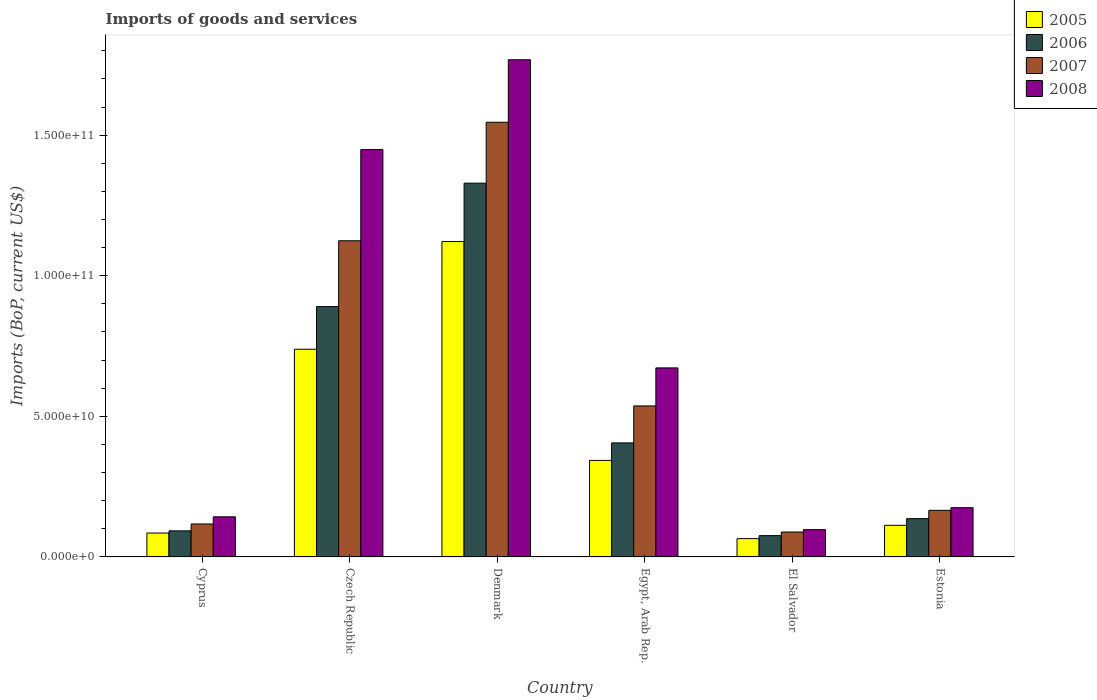How many different coloured bars are there?
Provide a succinct answer. 4. How many groups of bars are there?
Give a very brief answer. 6. Are the number of bars per tick equal to the number of legend labels?
Provide a short and direct response. Yes. Are the number of bars on each tick of the X-axis equal?
Your answer should be very brief. Yes. How many bars are there on the 2nd tick from the right?
Your answer should be very brief. 4. What is the label of the 2nd group of bars from the left?
Keep it short and to the point. Czech Republic. What is the amount spent on imports in 2007 in El Salvador?
Your answer should be very brief. 8.86e+09. Across all countries, what is the maximum amount spent on imports in 2005?
Offer a very short reply. 1.12e+11. Across all countries, what is the minimum amount spent on imports in 2005?
Your answer should be compact. 6.51e+09. In which country was the amount spent on imports in 2005 minimum?
Provide a succinct answer. El Salvador. What is the total amount spent on imports in 2005 in the graph?
Make the answer very short. 2.47e+11. What is the difference between the amount spent on imports in 2006 in Czech Republic and that in Egypt, Arab Rep.?
Offer a very short reply. 4.85e+1. What is the difference between the amount spent on imports in 2005 in Estonia and the amount spent on imports in 2006 in Denmark?
Ensure brevity in your answer.  -1.22e+11. What is the average amount spent on imports in 2008 per country?
Make the answer very short. 7.17e+1. What is the difference between the amount spent on imports of/in 2007 and amount spent on imports of/in 2006 in Cyprus?
Your response must be concise. 2.45e+09. In how many countries, is the amount spent on imports in 2007 greater than 100000000000 US$?
Provide a short and direct response. 2. What is the ratio of the amount spent on imports in 2006 in Egypt, Arab Rep. to that in Estonia?
Make the answer very short. 2.98. Is the amount spent on imports in 2008 in Czech Republic less than that in Estonia?
Your response must be concise. No. What is the difference between the highest and the second highest amount spent on imports in 2006?
Offer a very short reply. 9.24e+1. What is the difference between the highest and the lowest amount spent on imports in 2006?
Make the answer very short. 1.25e+11. Is the sum of the amount spent on imports in 2007 in Denmark and Estonia greater than the maximum amount spent on imports in 2005 across all countries?
Make the answer very short. Yes. What does the 4th bar from the left in Egypt, Arab Rep. represents?
Your answer should be very brief. 2008. What does the 1st bar from the right in Denmark represents?
Provide a short and direct response. 2008. Is it the case that in every country, the sum of the amount spent on imports in 2005 and amount spent on imports in 2007 is greater than the amount spent on imports in 2008?
Your response must be concise. Yes. How many bars are there?
Your answer should be very brief. 24. How many countries are there in the graph?
Offer a terse response. 6. What is the difference between two consecutive major ticks on the Y-axis?
Your response must be concise. 5.00e+1. Are the values on the major ticks of Y-axis written in scientific E-notation?
Your response must be concise. Yes. Does the graph contain any zero values?
Your answer should be compact. No. Does the graph contain grids?
Your answer should be very brief. No. How many legend labels are there?
Your answer should be very brief. 4. What is the title of the graph?
Provide a short and direct response. Imports of goods and services. What is the label or title of the Y-axis?
Your answer should be compact. Imports (BoP, current US$). What is the Imports (BoP, current US$) in 2005 in Cyprus?
Provide a succinct answer. 8.50e+09. What is the Imports (BoP, current US$) in 2006 in Cyprus?
Provide a short and direct response. 9.27e+09. What is the Imports (BoP, current US$) in 2007 in Cyprus?
Provide a short and direct response. 1.17e+1. What is the Imports (BoP, current US$) of 2008 in Cyprus?
Your answer should be compact. 1.43e+1. What is the Imports (BoP, current US$) of 2005 in Czech Republic?
Keep it short and to the point. 7.39e+1. What is the Imports (BoP, current US$) in 2006 in Czech Republic?
Make the answer very short. 8.90e+1. What is the Imports (BoP, current US$) of 2007 in Czech Republic?
Your response must be concise. 1.12e+11. What is the Imports (BoP, current US$) of 2008 in Czech Republic?
Ensure brevity in your answer.  1.45e+11. What is the Imports (BoP, current US$) in 2005 in Denmark?
Your answer should be compact. 1.12e+11. What is the Imports (BoP, current US$) of 2006 in Denmark?
Offer a terse response. 1.33e+11. What is the Imports (BoP, current US$) of 2007 in Denmark?
Make the answer very short. 1.55e+11. What is the Imports (BoP, current US$) in 2008 in Denmark?
Your answer should be very brief. 1.77e+11. What is the Imports (BoP, current US$) of 2005 in Egypt, Arab Rep.?
Offer a terse response. 3.43e+1. What is the Imports (BoP, current US$) in 2006 in Egypt, Arab Rep.?
Provide a succinct answer. 4.06e+1. What is the Imports (BoP, current US$) of 2007 in Egypt, Arab Rep.?
Make the answer very short. 5.37e+1. What is the Imports (BoP, current US$) in 2008 in Egypt, Arab Rep.?
Ensure brevity in your answer.  6.72e+1. What is the Imports (BoP, current US$) in 2005 in El Salvador?
Your answer should be compact. 6.51e+09. What is the Imports (BoP, current US$) in 2006 in El Salvador?
Make the answer very short. 7.57e+09. What is the Imports (BoP, current US$) in 2007 in El Salvador?
Your answer should be compact. 8.86e+09. What is the Imports (BoP, current US$) in 2008 in El Salvador?
Provide a short and direct response. 9.70e+09. What is the Imports (BoP, current US$) of 2005 in Estonia?
Provide a short and direct response. 1.12e+1. What is the Imports (BoP, current US$) of 2006 in Estonia?
Give a very brief answer. 1.36e+1. What is the Imports (BoP, current US$) of 2007 in Estonia?
Your answer should be compact. 1.66e+1. What is the Imports (BoP, current US$) of 2008 in Estonia?
Give a very brief answer. 1.75e+1. Across all countries, what is the maximum Imports (BoP, current US$) of 2005?
Offer a terse response. 1.12e+11. Across all countries, what is the maximum Imports (BoP, current US$) in 2006?
Offer a very short reply. 1.33e+11. Across all countries, what is the maximum Imports (BoP, current US$) of 2007?
Ensure brevity in your answer.  1.55e+11. Across all countries, what is the maximum Imports (BoP, current US$) in 2008?
Ensure brevity in your answer.  1.77e+11. Across all countries, what is the minimum Imports (BoP, current US$) in 2005?
Your response must be concise. 6.51e+09. Across all countries, what is the minimum Imports (BoP, current US$) of 2006?
Ensure brevity in your answer.  7.57e+09. Across all countries, what is the minimum Imports (BoP, current US$) of 2007?
Your answer should be very brief. 8.86e+09. Across all countries, what is the minimum Imports (BoP, current US$) in 2008?
Your answer should be very brief. 9.70e+09. What is the total Imports (BoP, current US$) of 2005 in the graph?
Keep it short and to the point. 2.47e+11. What is the total Imports (BoP, current US$) in 2006 in the graph?
Offer a very short reply. 2.93e+11. What is the total Imports (BoP, current US$) of 2007 in the graph?
Make the answer very short. 3.58e+11. What is the total Imports (BoP, current US$) in 2008 in the graph?
Give a very brief answer. 4.30e+11. What is the difference between the Imports (BoP, current US$) of 2005 in Cyprus and that in Czech Republic?
Provide a short and direct response. -6.54e+1. What is the difference between the Imports (BoP, current US$) in 2006 in Cyprus and that in Czech Republic?
Your response must be concise. -7.97e+1. What is the difference between the Imports (BoP, current US$) of 2007 in Cyprus and that in Czech Republic?
Keep it short and to the point. -1.01e+11. What is the difference between the Imports (BoP, current US$) in 2008 in Cyprus and that in Czech Republic?
Make the answer very short. -1.31e+11. What is the difference between the Imports (BoP, current US$) in 2005 in Cyprus and that in Denmark?
Ensure brevity in your answer.  -1.04e+11. What is the difference between the Imports (BoP, current US$) in 2006 in Cyprus and that in Denmark?
Offer a very short reply. -1.24e+11. What is the difference between the Imports (BoP, current US$) in 2007 in Cyprus and that in Denmark?
Provide a short and direct response. -1.43e+11. What is the difference between the Imports (BoP, current US$) in 2008 in Cyprus and that in Denmark?
Make the answer very short. -1.63e+11. What is the difference between the Imports (BoP, current US$) of 2005 in Cyprus and that in Egypt, Arab Rep.?
Offer a terse response. -2.58e+1. What is the difference between the Imports (BoP, current US$) of 2006 in Cyprus and that in Egypt, Arab Rep.?
Offer a very short reply. -3.13e+1. What is the difference between the Imports (BoP, current US$) of 2007 in Cyprus and that in Egypt, Arab Rep.?
Provide a short and direct response. -4.20e+1. What is the difference between the Imports (BoP, current US$) of 2008 in Cyprus and that in Egypt, Arab Rep.?
Your response must be concise. -5.30e+1. What is the difference between the Imports (BoP, current US$) in 2005 in Cyprus and that in El Salvador?
Keep it short and to the point. 1.99e+09. What is the difference between the Imports (BoP, current US$) of 2006 in Cyprus and that in El Salvador?
Offer a very short reply. 1.70e+09. What is the difference between the Imports (BoP, current US$) in 2007 in Cyprus and that in El Salvador?
Keep it short and to the point. 2.87e+09. What is the difference between the Imports (BoP, current US$) of 2008 in Cyprus and that in El Salvador?
Offer a terse response. 4.56e+09. What is the difference between the Imports (BoP, current US$) in 2005 in Cyprus and that in Estonia?
Your answer should be compact. -2.75e+09. What is the difference between the Imports (BoP, current US$) in 2006 in Cyprus and that in Estonia?
Make the answer very short. -4.34e+09. What is the difference between the Imports (BoP, current US$) in 2007 in Cyprus and that in Estonia?
Ensure brevity in your answer.  -4.85e+09. What is the difference between the Imports (BoP, current US$) in 2008 in Cyprus and that in Estonia?
Offer a terse response. -3.25e+09. What is the difference between the Imports (BoP, current US$) in 2005 in Czech Republic and that in Denmark?
Offer a terse response. -3.83e+1. What is the difference between the Imports (BoP, current US$) in 2006 in Czech Republic and that in Denmark?
Make the answer very short. -4.39e+1. What is the difference between the Imports (BoP, current US$) of 2007 in Czech Republic and that in Denmark?
Make the answer very short. -4.21e+1. What is the difference between the Imports (BoP, current US$) of 2008 in Czech Republic and that in Denmark?
Ensure brevity in your answer.  -3.19e+1. What is the difference between the Imports (BoP, current US$) of 2005 in Czech Republic and that in Egypt, Arab Rep.?
Provide a short and direct response. 3.95e+1. What is the difference between the Imports (BoP, current US$) in 2006 in Czech Republic and that in Egypt, Arab Rep.?
Offer a very short reply. 4.85e+1. What is the difference between the Imports (BoP, current US$) of 2007 in Czech Republic and that in Egypt, Arab Rep.?
Provide a short and direct response. 5.87e+1. What is the difference between the Imports (BoP, current US$) of 2008 in Czech Republic and that in Egypt, Arab Rep.?
Your answer should be compact. 7.76e+1. What is the difference between the Imports (BoP, current US$) of 2005 in Czech Republic and that in El Salvador?
Offer a terse response. 6.74e+1. What is the difference between the Imports (BoP, current US$) of 2006 in Czech Republic and that in El Salvador?
Your response must be concise. 8.15e+1. What is the difference between the Imports (BoP, current US$) in 2007 in Czech Republic and that in El Salvador?
Your answer should be very brief. 1.04e+11. What is the difference between the Imports (BoP, current US$) in 2008 in Czech Republic and that in El Salvador?
Provide a succinct answer. 1.35e+11. What is the difference between the Imports (BoP, current US$) in 2005 in Czech Republic and that in Estonia?
Make the answer very short. 6.26e+1. What is the difference between the Imports (BoP, current US$) of 2006 in Czech Republic and that in Estonia?
Provide a succinct answer. 7.54e+1. What is the difference between the Imports (BoP, current US$) of 2007 in Czech Republic and that in Estonia?
Offer a terse response. 9.59e+1. What is the difference between the Imports (BoP, current US$) in 2008 in Czech Republic and that in Estonia?
Your response must be concise. 1.27e+11. What is the difference between the Imports (BoP, current US$) of 2005 in Denmark and that in Egypt, Arab Rep.?
Give a very brief answer. 7.78e+1. What is the difference between the Imports (BoP, current US$) in 2006 in Denmark and that in Egypt, Arab Rep.?
Provide a succinct answer. 9.24e+1. What is the difference between the Imports (BoP, current US$) of 2007 in Denmark and that in Egypt, Arab Rep.?
Your response must be concise. 1.01e+11. What is the difference between the Imports (BoP, current US$) in 2008 in Denmark and that in Egypt, Arab Rep.?
Give a very brief answer. 1.10e+11. What is the difference between the Imports (BoP, current US$) of 2005 in Denmark and that in El Salvador?
Make the answer very short. 1.06e+11. What is the difference between the Imports (BoP, current US$) of 2006 in Denmark and that in El Salvador?
Give a very brief answer. 1.25e+11. What is the difference between the Imports (BoP, current US$) in 2007 in Denmark and that in El Salvador?
Provide a short and direct response. 1.46e+11. What is the difference between the Imports (BoP, current US$) in 2008 in Denmark and that in El Salvador?
Your answer should be compact. 1.67e+11. What is the difference between the Imports (BoP, current US$) in 2005 in Denmark and that in Estonia?
Offer a very short reply. 1.01e+11. What is the difference between the Imports (BoP, current US$) of 2006 in Denmark and that in Estonia?
Keep it short and to the point. 1.19e+11. What is the difference between the Imports (BoP, current US$) in 2007 in Denmark and that in Estonia?
Provide a succinct answer. 1.38e+11. What is the difference between the Imports (BoP, current US$) in 2008 in Denmark and that in Estonia?
Offer a very short reply. 1.59e+11. What is the difference between the Imports (BoP, current US$) in 2005 in Egypt, Arab Rep. and that in El Salvador?
Your answer should be compact. 2.78e+1. What is the difference between the Imports (BoP, current US$) of 2006 in Egypt, Arab Rep. and that in El Salvador?
Your response must be concise. 3.30e+1. What is the difference between the Imports (BoP, current US$) in 2007 in Egypt, Arab Rep. and that in El Salvador?
Your response must be concise. 4.48e+1. What is the difference between the Imports (BoP, current US$) of 2008 in Egypt, Arab Rep. and that in El Salvador?
Your response must be concise. 5.75e+1. What is the difference between the Imports (BoP, current US$) of 2005 in Egypt, Arab Rep. and that in Estonia?
Offer a very short reply. 2.31e+1. What is the difference between the Imports (BoP, current US$) in 2006 in Egypt, Arab Rep. and that in Estonia?
Offer a very short reply. 2.69e+1. What is the difference between the Imports (BoP, current US$) of 2007 in Egypt, Arab Rep. and that in Estonia?
Keep it short and to the point. 3.71e+1. What is the difference between the Imports (BoP, current US$) in 2008 in Egypt, Arab Rep. and that in Estonia?
Your answer should be compact. 4.97e+1. What is the difference between the Imports (BoP, current US$) in 2005 in El Salvador and that in Estonia?
Make the answer very short. -4.74e+09. What is the difference between the Imports (BoP, current US$) in 2006 in El Salvador and that in Estonia?
Your answer should be very brief. -6.05e+09. What is the difference between the Imports (BoP, current US$) in 2007 in El Salvador and that in Estonia?
Offer a terse response. -7.72e+09. What is the difference between the Imports (BoP, current US$) in 2008 in El Salvador and that in Estonia?
Keep it short and to the point. -7.81e+09. What is the difference between the Imports (BoP, current US$) of 2005 in Cyprus and the Imports (BoP, current US$) of 2006 in Czech Republic?
Make the answer very short. -8.05e+1. What is the difference between the Imports (BoP, current US$) in 2005 in Cyprus and the Imports (BoP, current US$) in 2007 in Czech Republic?
Ensure brevity in your answer.  -1.04e+11. What is the difference between the Imports (BoP, current US$) of 2005 in Cyprus and the Imports (BoP, current US$) of 2008 in Czech Republic?
Your answer should be very brief. -1.36e+11. What is the difference between the Imports (BoP, current US$) in 2006 in Cyprus and the Imports (BoP, current US$) in 2007 in Czech Republic?
Offer a terse response. -1.03e+11. What is the difference between the Imports (BoP, current US$) in 2006 in Cyprus and the Imports (BoP, current US$) in 2008 in Czech Republic?
Give a very brief answer. -1.36e+11. What is the difference between the Imports (BoP, current US$) of 2007 in Cyprus and the Imports (BoP, current US$) of 2008 in Czech Republic?
Make the answer very short. -1.33e+11. What is the difference between the Imports (BoP, current US$) of 2005 in Cyprus and the Imports (BoP, current US$) of 2006 in Denmark?
Your response must be concise. -1.24e+11. What is the difference between the Imports (BoP, current US$) of 2005 in Cyprus and the Imports (BoP, current US$) of 2007 in Denmark?
Your answer should be compact. -1.46e+11. What is the difference between the Imports (BoP, current US$) in 2005 in Cyprus and the Imports (BoP, current US$) in 2008 in Denmark?
Offer a very short reply. -1.68e+11. What is the difference between the Imports (BoP, current US$) of 2006 in Cyprus and the Imports (BoP, current US$) of 2007 in Denmark?
Provide a short and direct response. -1.45e+11. What is the difference between the Imports (BoP, current US$) of 2006 in Cyprus and the Imports (BoP, current US$) of 2008 in Denmark?
Ensure brevity in your answer.  -1.68e+11. What is the difference between the Imports (BoP, current US$) in 2007 in Cyprus and the Imports (BoP, current US$) in 2008 in Denmark?
Provide a short and direct response. -1.65e+11. What is the difference between the Imports (BoP, current US$) of 2005 in Cyprus and the Imports (BoP, current US$) of 2006 in Egypt, Arab Rep.?
Your answer should be very brief. -3.21e+1. What is the difference between the Imports (BoP, current US$) of 2005 in Cyprus and the Imports (BoP, current US$) of 2007 in Egypt, Arab Rep.?
Your answer should be compact. -4.52e+1. What is the difference between the Imports (BoP, current US$) in 2005 in Cyprus and the Imports (BoP, current US$) in 2008 in Egypt, Arab Rep.?
Offer a very short reply. -5.87e+1. What is the difference between the Imports (BoP, current US$) of 2006 in Cyprus and the Imports (BoP, current US$) of 2007 in Egypt, Arab Rep.?
Keep it short and to the point. -4.44e+1. What is the difference between the Imports (BoP, current US$) in 2006 in Cyprus and the Imports (BoP, current US$) in 2008 in Egypt, Arab Rep.?
Ensure brevity in your answer.  -5.79e+1. What is the difference between the Imports (BoP, current US$) in 2007 in Cyprus and the Imports (BoP, current US$) in 2008 in Egypt, Arab Rep.?
Your answer should be very brief. -5.55e+1. What is the difference between the Imports (BoP, current US$) in 2005 in Cyprus and the Imports (BoP, current US$) in 2006 in El Salvador?
Give a very brief answer. 9.27e+08. What is the difference between the Imports (BoP, current US$) of 2005 in Cyprus and the Imports (BoP, current US$) of 2007 in El Salvador?
Provide a short and direct response. -3.57e+08. What is the difference between the Imports (BoP, current US$) in 2005 in Cyprus and the Imports (BoP, current US$) in 2008 in El Salvador?
Your answer should be very brief. -1.20e+09. What is the difference between the Imports (BoP, current US$) of 2006 in Cyprus and the Imports (BoP, current US$) of 2007 in El Salvador?
Your answer should be compact. 4.18e+08. What is the difference between the Imports (BoP, current US$) of 2006 in Cyprus and the Imports (BoP, current US$) of 2008 in El Salvador?
Provide a succinct answer. -4.26e+08. What is the difference between the Imports (BoP, current US$) of 2007 in Cyprus and the Imports (BoP, current US$) of 2008 in El Salvador?
Provide a succinct answer. 2.02e+09. What is the difference between the Imports (BoP, current US$) in 2005 in Cyprus and the Imports (BoP, current US$) in 2006 in Estonia?
Provide a succinct answer. -5.12e+09. What is the difference between the Imports (BoP, current US$) in 2005 in Cyprus and the Imports (BoP, current US$) in 2007 in Estonia?
Make the answer very short. -8.07e+09. What is the difference between the Imports (BoP, current US$) in 2005 in Cyprus and the Imports (BoP, current US$) in 2008 in Estonia?
Keep it short and to the point. -9.02e+09. What is the difference between the Imports (BoP, current US$) in 2006 in Cyprus and the Imports (BoP, current US$) in 2007 in Estonia?
Make the answer very short. -7.30e+09. What is the difference between the Imports (BoP, current US$) of 2006 in Cyprus and the Imports (BoP, current US$) of 2008 in Estonia?
Provide a short and direct response. -8.24e+09. What is the difference between the Imports (BoP, current US$) of 2007 in Cyprus and the Imports (BoP, current US$) of 2008 in Estonia?
Ensure brevity in your answer.  -5.79e+09. What is the difference between the Imports (BoP, current US$) of 2005 in Czech Republic and the Imports (BoP, current US$) of 2006 in Denmark?
Your response must be concise. -5.91e+1. What is the difference between the Imports (BoP, current US$) of 2005 in Czech Republic and the Imports (BoP, current US$) of 2007 in Denmark?
Your answer should be compact. -8.07e+1. What is the difference between the Imports (BoP, current US$) in 2005 in Czech Republic and the Imports (BoP, current US$) in 2008 in Denmark?
Make the answer very short. -1.03e+11. What is the difference between the Imports (BoP, current US$) of 2006 in Czech Republic and the Imports (BoP, current US$) of 2007 in Denmark?
Offer a very short reply. -6.56e+1. What is the difference between the Imports (BoP, current US$) in 2006 in Czech Republic and the Imports (BoP, current US$) in 2008 in Denmark?
Your answer should be very brief. -8.78e+1. What is the difference between the Imports (BoP, current US$) in 2007 in Czech Republic and the Imports (BoP, current US$) in 2008 in Denmark?
Keep it short and to the point. -6.44e+1. What is the difference between the Imports (BoP, current US$) of 2005 in Czech Republic and the Imports (BoP, current US$) of 2006 in Egypt, Arab Rep.?
Your answer should be very brief. 3.33e+1. What is the difference between the Imports (BoP, current US$) in 2005 in Czech Republic and the Imports (BoP, current US$) in 2007 in Egypt, Arab Rep.?
Give a very brief answer. 2.02e+1. What is the difference between the Imports (BoP, current US$) in 2005 in Czech Republic and the Imports (BoP, current US$) in 2008 in Egypt, Arab Rep.?
Your response must be concise. 6.64e+09. What is the difference between the Imports (BoP, current US$) in 2006 in Czech Republic and the Imports (BoP, current US$) in 2007 in Egypt, Arab Rep.?
Give a very brief answer. 3.53e+1. What is the difference between the Imports (BoP, current US$) of 2006 in Czech Republic and the Imports (BoP, current US$) of 2008 in Egypt, Arab Rep.?
Offer a terse response. 2.18e+1. What is the difference between the Imports (BoP, current US$) of 2007 in Czech Republic and the Imports (BoP, current US$) of 2008 in Egypt, Arab Rep.?
Give a very brief answer. 4.52e+1. What is the difference between the Imports (BoP, current US$) in 2005 in Czech Republic and the Imports (BoP, current US$) in 2006 in El Salvador?
Ensure brevity in your answer.  6.63e+1. What is the difference between the Imports (BoP, current US$) of 2005 in Czech Republic and the Imports (BoP, current US$) of 2007 in El Salvador?
Offer a very short reply. 6.50e+1. What is the difference between the Imports (BoP, current US$) of 2005 in Czech Republic and the Imports (BoP, current US$) of 2008 in El Salvador?
Offer a terse response. 6.42e+1. What is the difference between the Imports (BoP, current US$) in 2006 in Czech Republic and the Imports (BoP, current US$) in 2007 in El Salvador?
Ensure brevity in your answer.  8.02e+1. What is the difference between the Imports (BoP, current US$) of 2006 in Czech Republic and the Imports (BoP, current US$) of 2008 in El Salvador?
Provide a short and direct response. 7.93e+1. What is the difference between the Imports (BoP, current US$) in 2007 in Czech Republic and the Imports (BoP, current US$) in 2008 in El Salvador?
Your answer should be compact. 1.03e+11. What is the difference between the Imports (BoP, current US$) of 2005 in Czech Republic and the Imports (BoP, current US$) of 2006 in Estonia?
Your answer should be compact. 6.02e+1. What is the difference between the Imports (BoP, current US$) of 2005 in Czech Republic and the Imports (BoP, current US$) of 2007 in Estonia?
Provide a short and direct response. 5.73e+1. What is the difference between the Imports (BoP, current US$) in 2005 in Czech Republic and the Imports (BoP, current US$) in 2008 in Estonia?
Provide a short and direct response. 5.64e+1. What is the difference between the Imports (BoP, current US$) of 2006 in Czech Republic and the Imports (BoP, current US$) of 2007 in Estonia?
Offer a terse response. 7.25e+1. What is the difference between the Imports (BoP, current US$) in 2006 in Czech Republic and the Imports (BoP, current US$) in 2008 in Estonia?
Make the answer very short. 7.15e+1. What is the difference between the Imports (BoP, current US$) of 2007 in Czech Republic and the Imports (BoP, current US$) of 2008 in Estonia?
Offer a very short reply. 9.49e+1. What is the difference between the Imports (BoP, current US$) of 2005 in Denmark and the Imports (BoP, current US$) of 2006 in Egypt, Arab Rep.?
Offer a terse response. 7.16e+1. What is the difference between the Imports (BoP, current US$) in 2005 in Denmark and the Imports (BoP, current US$) in 2007 in Egypt, Arab Rep.?
Your response must be concise. 5.85e+1. What is the difference between the Imports (BoP, current US$) in 2005 in Denmark and the Imports (BoP, current US$) in 2008 in Egypt, Arab Rep.?
Ensure brevity in your answer.  4.49e+1. What is the difference between the Imports (BoP, current US$) in 2006 in Denmark and the Imports (BoP, current US$) in 2007 in Egypt, Arab Rep.?
Provide a short and direct response. 7.92e+1. What is the difference between the Imports (BoP, current US$) of 2006 in Denmark and the Imports (BoP, current US$) of 2008 in Egypt, Arab Rep.?
Offer a terse response. 6.57e+1. What is the difference between the Imports (BoP, current US$) in 2007 in Denmark and the Imports (BoP, current US$) in 2008 in Egypt, Arab Rep.?
Make the answer very short. 8.74e+1. What is the difference between the Imports (BoP, current US$) in 2005 in Denmark and the Imports (BoP, current US$) in 2006 in El Salvador?
Provide a short and direct response. 1.05e+11. What is the difference between the Imports (BoP, current US$) in 2005 in Denmark and the Imports (BoP, current US$) in 2007 in El Salvador?
Provide a succinct answer. 1.03e+11. What is the difference between the Imports (BoP, current US$) of 2005 in Denmark and the Imports (BoP, current US$) of 2008 in El Salvador?
Give a very brief answer. 1.02e+11. What is the difference between the Imports (BoP, current US$) in 2006 in Denmark and the Imports (BoP, current US$) in 2007 in El Salvador?
Offer a very short reply. 1.24e+11. What is the difference between the Imports (BoP, current US$) of 2006 in Denmark and the Imports (BoP, current US$) of 2008 in El Salvador?
Provide a succinct answer. 1.23e+11. What is the difference between the Imports (BoP, current US$) of 2007 in Denmark and the Imports (BoP, current US$) of 2008 in El Salvador?
Give a very brief answer. 1.45e+11. What is the difference between the Imports (BoP, current US$) of 2005 in Denmark and the Imports (BoP, current US$) of 2006 in Estonia?
Make the answer very short. 9.85e+1. What is the difference between the Imports (BoP, current US$) of 2005 in Denmark and the Imports (BoP, current US$) of 2007 in Estonia?
Give a very brief answer. 9.56e+1. What is the difference between the Imports (BoP, current US$) of 2005 in Denmark and the Imports (BoP, current US$) of 2008 in Estonia?
Ensure brevity in your answer.  9.46e+1. What is the difference between the Imports (BoP, current US$) in 2006 in Denmark and the Imports (BoP, current US$) in 2007 in Estonia?
Ensure brevity in your answer.  1.16e+11. What is the difference between the Imports (BoP, current US$) of 2006 in Denmark and the Imports (BoP, current US$) of 2008 in Estonia?
Offer a very short reply. 1.15e+11. What is the difference between the Imports (BoP, current US$) in 2007 in Denmark and the Imports (BoP, current US$) in 2008 in Estonia?
Provide a succinct answer. 1.37e+11. What is the difference between the Imports (BoP, current US$) in 2005 in Egypt, Arab Rep. and the Imports (BoP, current US$) in 2006 in El Salvador?
Give a very brief answer. 2.68e+1. What is the difference between the Imports (BoP, current US$) of 2005 in Egypt, Arab Rep. and the Imports (BoP, current US$) of 2007 in El Salvador?
Ensure brevity in your answer.  2.55e+1. What is the difference between the Imports (BoP, current US$) of 2005 in Egypt, Arab Rep. and the Imports (BoP, current US$) of 2008 in El Salvador?
Your answer should be very brief. 2.46e+1. What is the difference between the Imports (BoP, current US$) of 2006 in Egypt, Arab Rep. and the Imports (BoP, current US$) of 2007 in El Salvador?
Provide a short and direct response. 3.17e+1. What is the difference between the Imports (BoP, current US$) in 2006 in Egypt, Arab Rep. and the Imports (BoP, current US$) in 2008 in El Salvador?
Offer a very short reply. 3.09e+1. What is the difference between the Imports (BoP, current US$) in 2007 in Egypt, Arab Rep. and the Imports (BoP, current US$) in 2008 in El Salvador?
Offer a terse response. 4.40e+1. What is the difference between the Imports (BoP, current US$) in 2005 in Egypt, Arab Rep. and the Imports (BoP, current US$) in 2006 in Estonia?
Your answer should be very brief. 2.07e+1. What is the difference between the Imports (BoP, current US$) of 2005 in Egypt, Arab Rep. and the Imports (BoP, current US$) of 2007 in Estonia?
Your response must be concise. 1.78e+1. What is the difference between the Imports (BoP, current US$) in 2005 in Egypt, Arab Rep. and the Imports (BoP, current US$) in 2008 in Estonia?
Your answer should be compact. 1.68e+1. What is the difference between the Imports (BoP, current US$) of 2006 in Egypt, Arab Rep. and the Imports (BoP, current US$) of 2007 in Estonia?
Your response must be concise. 2.40e+1. What is the difference between the Imports (BoP, current US$) of 2006 in Egypt, Arab Rep. and the Imports (BoP, current US$) of 2008 in Estonia?
Provide a succinct answer. 2.30e+1. What is the difference between the Imports (BoP, current US$) of 2007 in Egypt, Arab Rep. and the Imports (BoP, current US$) of 2008 in Estonia?
Provide a succinct answer. 3.62e+1. What is the difference between the Imports (BoP, current US$) of 2005 in El Salvador and the Imports (BoP, current US$) of 2006 in Estonia?
Ensure brevity in your answer.  -7.11e+09. What is the difference between the Imports (BoP, current US$) of 2005 in El Salvador and the Imports (BoP, current US$) of 2007 in Estonia?
Give a very brief answer. -1.01e+1. What is the difference between the Imports (BoP, current US$) in 2005 in El Salvador and the Imports (BoP, current US$) in 2008 in Estonia?
Provide a short and direct response. -1.10e+1. What is the difference between the Imports (BoP, current US$) in 2006 in El Salvador and the Imports (BoP, current US$) in 2007 in Estonia?
Keep it short and to the point. -9.00e+09. What is the difference between the Imports (BoP, current US$) of 2006 in El Salvador and the Imports (BoP, current US$) of 2008 in Estonia?
Offer a terse response. -9.94e+09. What is the difference between the Imports (BoP, current US$) of 2007 in El Salvador and the Imports (BoP, current US$) of 2008 in Estonia?
Give a very brief answer. -8.66e+09. What is the average Imports (BoP, current US$) in 2005 per country?
Your response must be concise. 4.11e+1. What is the average Imports (BoP, current US$) in 2006 per country?
Keep it short and to the point. 4.88e+1. What is the average Imports (BoP, current US$) in 2007 per country?
Your answer should be very brief. 5.96e+1. What is the average Imports (BoP, current US$) in 2008 per country?
Your response must be concise. 7.17e+1. What is the difference between the Imports (BoP, current US$) of 2005 and Imports (BoP, current US$) of 2006 in Cyprus?
Your answer should be compact. -7.76e+08. What is the difference between the Imports (BoP, current US$) in 2005 and Imports (BoP, current US$) in 2007 in Cyprus?
Provide a short and direct response. -3.22e+09. What is the difference between the Imports (BoP, current US$) in 2005 and Imports (BoP, current US$) in 2008 in Cyprus?
Keep it short and to the point. -5.77e+09. What is the difference between the Imports (BoP, current US$) of 2006 and Imports (BoP, current US$) of 2007 in Cyprus?
Offer a very short reply. -2.45e+09. What is the difference between the Imports (BoP, current US$) in 2006 and Imports (BoP, current US$) in 2008 in Cyprus?
Offer a terse response. -4.99e+09. What is the difference between the Imports (BoP, current US$) in 2007 and Imports (BoP, current US$) in 2008 in Cyprus?
Give a very brief answer. -2.54e+09. What is the difference between the Imports (BoP, current US$) in 2005 and Imports (BoP, current US$) in 2006 in Czech Republic?
Offer a terse response. -1.52e+1. What is the difference between the Imports (BoP, current US$) of 2005 and Imports (BoP, current US$) of 2007 in Czech Republic?
Provide a succinct answer. -3.86e+1. What is the difference between the Imports (BoP, current US$) in 2005 and Imports (BoP, current US$) in 2008 in Czech Republic?
Keep it short and to the point. -7.10e+1. What is the difference between the Imports (BoP, current US$) in 2006 and Imports (BoP, current US$) in 2007 in Czech Republic?
Offer a terse response. -2.34e+1. What is the difference between the Imports (BoP, current US$) in 2006 and Imports (BoP, current US$) in 2008 in Czech Republic?
Give a very brief answer. -5.58e+1. What is the difference between the Imports (BoP, current US$) of 2007 and Imports (BoP, current US$) of 2008 in Czech Republic?
Your answer should be compact. -3.24e+1. What is the difference between the Imports (BoP, current US$) in 2005 and Imports (BoP, current US$) in 2006 in Denmark?
Give a very brief answer. -2.08e+1. What is the difference between the Imports (BoP, current US$) of 2005 and Imports (BoP, current US$) of 2007 in Denmark?
Ensure brevity in your answer.  -4.24e+1. What is the difference between the Imports (BoP, current US$) in 2005 and Imports (BoP, current US$) in 2008 in Denmark?
Your answer should be very brief. -6.47e+1. What is the difference between the Imports (BoP, current US$) in 2006 and Imports (BoP, current US$) in 2007 in Denmark?
Provide a succinct answer. -2.17e+1. What is the difference between the Imports (BoP, current US$) of 2006 and Imports (BoP, current US$) of 2008 in Denmark?
Provide a succinct answer. -4.39e+1. What is the difference between the Imports (BoP, current US$) in 2007 and Imports (BoP, current US$) in 2008 in Denmark?
Give a very brief answer. -2.22e+1. What is the difference between the Imports (BoP, current US$) of 2005 and Imports (BoP, current US$) of 2006 in Egypt, Arab Rep.?
Your response must be concise. -6.23e+09. What is the difference between the Imports (BoP, current US$) in 2005 and Imports (BoP, current US$) in 2007 in Egypt, Arab Rep.?
Provide a short and direct response. -1.94e+1. What is the difference between the Imports (BoP, current US$) of 2005 and Imports (BoP, current US$) of 2008 in Egypt, Arab Rep.?
Your response must be concise. -3.29e+1. What is the difference between the Imports (BoP, current US$) in 2006 and Imports (BoP, current US$) in 2007 in Egypt, Arab Rep.?
Offer a terse response. -1.31e+1. What is the difference between the Imports (BoP, current US$) in 2006 and Imports (BoP, current US$) in 2008 in Egypt, Arab Rep.?
Provide a short and direct response. -2.67e+1. What is the difference between the Imports (BoP, current US$) of 2007 and Imports (BoP, current US$) of 2008 in Egypt, Arab Rep.?
Provide a short and direct response. -1.35e+1. What is the difference between the Imports (BoP, current US$) of 2005 and Imports (BoP, current US$) of 2006 in El Salvador?
Offer a terse response. -1.06e+09. What is the difference between the Imports (BoP, current US$) in 2005 and Imports (BoP, current US$) in 2007 in El Salvador?
Your response must be concise. -2.35e+09. What is the difference between the Imports (BoP, current US$) of 2005 and Imports (BoP, current US$) of 2008 in El Salvador?
Your answer should be compact. -3.19e+09. What is the difference between the Imports (BoP, current US$) of 2006 and Imports (BoP, current US$) of 2007 in El Salvador?
Provide a short and direct response. -1.28e+09. What is the difference between the Imports (BoP, current US$) in 2006 and Imports (BoP, current US$) in 2008 in El Salvador?
Offer a terse response. -2.13e+09. What is the difference between the Imports (BoP, current US$) of 2007 and Imports (BoP, current US$) of 2008 in El Salvador?
Give a very brief answer. -8.44e+08. What is the difference between the Imports (BoP, current US$) in 2005 and Imports (BoP, current US$) in 2006 in Estonia?
Keep it short and to the point. -2.37e+09. What is the difference between the Imports (BoP, current US$) of 2005 and Imports (BoP, current US$) of 2007 in Estonia?
Ensure brevity in your answer.  -5.32e+09. What is the difference between the Imports (BoP, current US$) of 2005 and Imports (BoP, current US$) of 2008 in Estonia?
Make the answer very short. -6.27e+09. What is the difference between the Imports (BoP, current US$) of 2006 and Imports (BoP, current US$) of 2007 in Estonia?
Offer a terse response. -2.95e+09. What is the difference between the Imports (BoP, current US$) of 2006 and Imports (BoP, current US$) of 2008 in Estonia?
Make the answer very short. -3.90e+09. What is the difference between the Imports (BoP, current US$) of 2007 and Imports (BoP, current US$) of 2008 in Estonia?
Provide a succinct answer. -9.43e+08. What is the ratio of the Imports (BoP, current US$) of 2005 in Cyprus to that in Czech Republic?
Provide a succinct answer. 0.12. What is the ratio of the Imports (BoP, current US$) of 2006 in Cyprus to that in Czech Republic?
Offer a terse response. 0.1. What is the ratio of the Imports (BoP, current US$) in 2007 in Cyprus to that in Czech Republic?
Ensure brevity in your answer.  0.1. What is the ratio of the Imports (BoP, current US$) of 2008 in Cyprus to that in Czech Republic?
Provide a short and direct response. 0.1. What is the ratio of the Imports (BoP, current US$) of 2005 in Cyprus to that in Denmark?
Keep it short and to the point. 0.08. What is the ratio of the Imports (BoP, current US$) in 2006 in Cyprus to that in Denmark?
Your answer should be compact. 0.07. What is the ratio of the Imports (BoP, current US$) in 2007 in Cyprus to that in Denmark?
Make the answer very short. 0.08. What is the ratio of the Imports (BoP, current US$) in 2008 in Cyprus to that in Denmark?
Offer a very short reply. 0.08. What is the ratio of the Imports (BoP, current US$) in 2005 in Cyprus to that in Egypt, Arab Rep.?
Provide a succinct answer. 0.25. What is the ratio of the Imports (BoP, current US$) in 2006 in Cyprus to that in Egypt, Arab Rep.?
Provide a short and direct response. 0.23. What is the ratio of the Imports (BoP, current US$) of 2007 in Cyprus to that in Egypt, Arab Rep.?
Keep it short and to the point. 0.22. What is the ratio of the Imports (BoP, current US$) in 2008 in Cyprus to that in Egypt, Arab Rep.?
Ensure brevity in your answer.  0.21. What is the ratio of the Imports (BoP, current US$) in 2005 in Cyprus to that in El Salvador?
Ensure brevity in your answer.  1.31. What is the ratio of the Imports (BoP, current US$) of 2006 in Cyprus to that in El Salvador?
Give a very brief answer. 1.22. What is the ratio of the Imports (BoP, current US$) in 2007 in Cyprus to that in El Salvador?
Your response must be concise. 1.32. What is the ratio of the Imports (BoP, current US$) of 2008 in Cyprus to that in El Salvador?
Ensure brevity in your answer.  1.47. What is the ratio of the Imports (BoP, current US$) in 2005 in Cyprus to that in Estonia?
Your answer should be compact. 0.76. What is the ratio of the Imports (BoP, current US$) in 2006 in Cyprus to that in Estonia?
Give a very brief answer. 0.68. What is the ratio of the Imports (BoP, current US$) of 2007 in Cyprus to that in Estonia?
Your answer should be compact. 0.71. What is the ratio of the Imports (BoP, current US$) in 2008 in Cyprus to that in Estonia?
Provide a short and direct response. 0.81. What is the ratio of the Imports (BoP, current US$) in 2005 in Czech Republic to that in Denmark?
Your response must be concise. 0.66. What is the ratio of the Imports (BoP, current US$) in 2006 in Czech Republic to that in Denmark?
Offer a terse response. 0.67. What is the ratio of the Imports (BoP, current US$) of 2007 in Czech Republic to that in Denmark?
Provide a short and direct response. 0.73. What is the ratio of the Imports (BoP, current US$) of 2008 in Czech Republic to that in Denmark?
Keep it short and to the point. 0.82. What is the ratio of the Imports (BoP, current US$) in 2005 in Czech Republic to that in Egypt, Arab Rep.?
Your answer should be compact. 2.15. What is the ratio of the Imports (BoP, current US$) of 2006 in Czech Republic to that in Egypt, Arab Rep.?
Ensure brevity in your answer.  2.2. What is the ratio of the Imports (BoP, current US$) of 2007 in Czech Republic to that in Egypt, Arab Rep.?
Ensure brevity in your answer.  2.09. What is the ratio of the Imports (BoP, current US$) in 2008 in Czech Republic to that in Egypt, Arab Rep.?
Offer a terse response. 2.16. What is the ratio of the Imports (BoP, current US$) of 2005 in Czech Republic to that in El Salvador?
Your answer should be very brief. 11.35. What is the ratio of the Imports (BoP, current US$) of 2006 in Czech Republic to that in El Salvador?
Ensure brevity in your answer.  11.76. What is the ratio of the Imports (BoP, current US$) in 2007 in Czech Republic to that in El Salvador?
Make the answer very short. 12.7. What is the ratio of the Imports (BoP, current US$) in 2008 in Czech Republic to that in El Salvador?
Keep it short and to the point. 14.94. What is the ratio of the Imports (BoP, current US$) in 2005 in Czech Republic to that in Estonia?
Your answer should be compact. 6.57. What is the ratio of the Imports (BoP, current US$) of 2006 in Czech Republic to that in Estonia?
Provide a short and direct response. 6.54. What is the ratio of the Imports (BoP, current US$) of 2007 in Czech Republic to that in Estonia?
Ensure brevity in your answer.  6.78. What is the ratio of the Imports (BoP, current US$) in 2008 in Czech Republic to that in Estonia?
Your response must be concise. 8.27. What is the ratio of the Imports (BoP, current US$) of 2005 in Denmark to that in Egypt, Arab Rep.?
Your answer should be very brief. 3.27. What is the ratio of the Imports (BoP, current US$) in 2006 in Denmark to that in Egypt, Arab Rep.?
Offer a terse response. 3.28. What is the ratio of the Imports (BoP, current US$) in 2007 in Denmark to that in Egypt, Arab Rep.?
Your answer should be very brief. 2.88. What is the ratio of the Imports (BoP, current US$) in 2008 in Denmark to that in Egypt, Arab Rep.?
Keep it short and to the point. 2.63. What is the ratio of the Imports (BoP, current US$) of 2005 in Denmark to that in El Salvador?
Ensure brevity in your answer.  17.23. What is the ratio of the Imports (BoP, current US$) of 2006 in Denmark to that in El Salvador?
Provide a succinct answer. 17.56. What is the ratio of the Imports (BoP, current US$) of 2007 in Denmark to that in El Salvador?
Provide a short and direct response. 17.46. What is the ratio of the Imports (BoP, current US$) in 2008 in Denmark to that in El Salvador?
Your answer should be compact. 18.23. What is the ratio of the Imports (BoP, current US$) of 2005 in Denmark to that in Estonia?
Offer a very short reply. 9.97. What is the ratio of the Imports (BoP, current US$) of 2006 in Denmark to that in Estonia?
Offer a very short reply. 9.76. What is the ratio of the Imports (BoP, current US$) of 2007 in Denmark to that in Estonia?
Keep it short and to the point. 9.33. What is the ratio of the Imports (BoP, current US$) of 2008 in Denmark to that in Estonia?
Give a very brief answer. 10.1. What is the ratio of the Imports (BoP, current US$) of 2005 in Egypt, Arab Rep. to that in El Salvador?
Your answer should be compact. 5.27. What is the ratio of the Imports (BoP, current US$) of 2006 in Egypt, Arab Rep. to that in El Salvador?
Provide a succinct answer. 5.36. What is the ratio of the Imports (BoP, current US$) of 2007 in Egypt, Arab Rep. to that in El Salvador?
Provide a succinct answer. 6.06. What is the ratio of the Imports (BoP, current US$) of 2008 in Egypt, Arab Rep. to that in El Salvador?
Make the answer very short. 6.93. What is the ratio of the Imports (BoP, current US$) in 2005 in Egypt, Arab Rep. to that in Estonia?
Your response must be concise. 3.05. What is the ratio of the Imports (BoP, current US$) of 2006 in Egypt, Arab Rep. to that in Estonia?
Ensure brevity in your answer.  2.98. What is the ratio of the Imports (BoP, current US$) in 2007 in Egypt, Arab Rep. to that in Estonia?
Provide a short and direct response. 3.24. What is the ratio of the Imports (BoP, current US$) in 2008 in Egypt, Arab Rep. to that in Estonia?
Provide a short and direct response. 3.84. What is the ratio of the Imports (BoP, current US$) in 2005 in El Salvador to that in Estonia?
Offer a terse response. 0.58. What is the ratio of the Imports (BoP, current US$) of 2006 in El Salvador to that in Estonia?
Make the answer very short. 0.56. What is the ratio of the Imports (BoP, current US$) in 2007 in El Salvador to that in Estonia?
Offer a terse response. 0.53. What is the ratio of the Imports (BoP, current US$) in 2008 in El Salvador to that in Estonia?
Provide a short and direct response. 0.55. What is the difference between the highest and the second highest Imports (BoP, current US$) of 2005?
Give a very brief answer. 3.83e+1. What is the difference between the highest and the second highest Imports (BoP, current US$) in 2006?
Offer a terse response. 4.39e+1. What is the difference between the highest and the second highest Imports (BoP, current US$) in 2007?
Give a very brief answer. 4.21e+1. What is the difference between the highest and the second highest Imports (BoP, current US$) in 2008?
Give a very brief answer. 3.19e+1. What is the difference between the highest and the lowest Imports (BoP, current US$) in 2005?
Your response must be concise. 1.06e+11. What is the difference between the highest and the lowest Imports (BoP, current US$) in 2006?
Your response must be concise. 1.25e+11. What is the difference between the highest and the lowest Imports (BoP, current US$) in 2007?
Ensure brevity in your answer.  1.46e+11. What is the difference between the highest and the lowest Imports (BoP, current US$) in 2008?
Ensure brevity in your answer.  1.67e+11. 